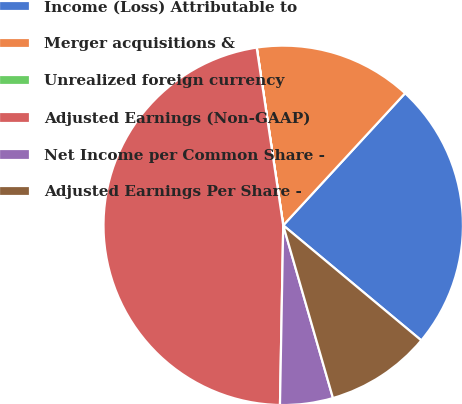<chart> <loc_0><loc_0><loc_500><loc_500><pie_chart><fcel>Income (Loss) Attributable to<fcel>Merger acquisitions &<fcel>Unrealized foreign currency<fcel>Adjusted Earnings (Non-GAAP)<fcel>Net Income per Common Share -<fcel>Adjusted Earnings Per Share -<nl><fcel>24.2%<fcel>14.21%<fcel>0.01%<fcel>47.35%<fcel>4.75%<fcel>9.48%<nl></chart> 